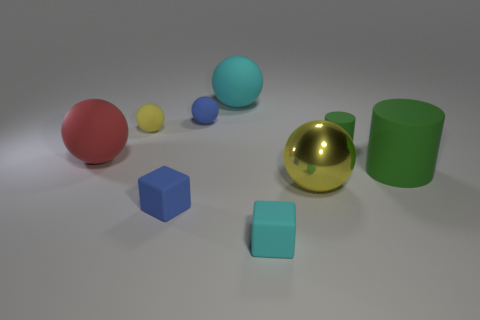What is the size of the other object that is the same color as the metal thing?
Your answer should be compact. Small. What is the size of the blue matte thing that is the same shape as the big cyan rubber object?
Your response must be concise. Small. There is a blue object behind the green rubber cylinder in front of the red matte ball; what is its shape?
Give a very brief answer. Sphere. What is the size of the cyan matte cube?
Keep it short and to the point. Small. What is the shape of the metal thing?
Provide a short and direct response. Sphere. Does the big yellow metallic object have the same shape as the cyan object in front of the red rubber thing?
Ensure brevity in your answer.  No. There is a big rubber thing on the right side of the tiny cyan rubber block; is it the same shape as the big yellow thing?
Provide a short and direct response. No. How many rubber objects are right of the small cyan rubber block and in front of the red sphere?
Ensure brevity in your answer.  1. What number of other objects are the same size as the yellow rubber sphere?
Offer a very short reply. 4. Are there an equal number of matte cubes on the right side of the tiny green rubber cylinder and green metal cubes?
Offer a very short reply. Yes. 